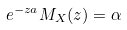Convert formula to latex. <formula><loc_0><loc_0><loc_500><loc_500>e ^ { - z a } M _ { X } ( z ) = \alpha</formula> 